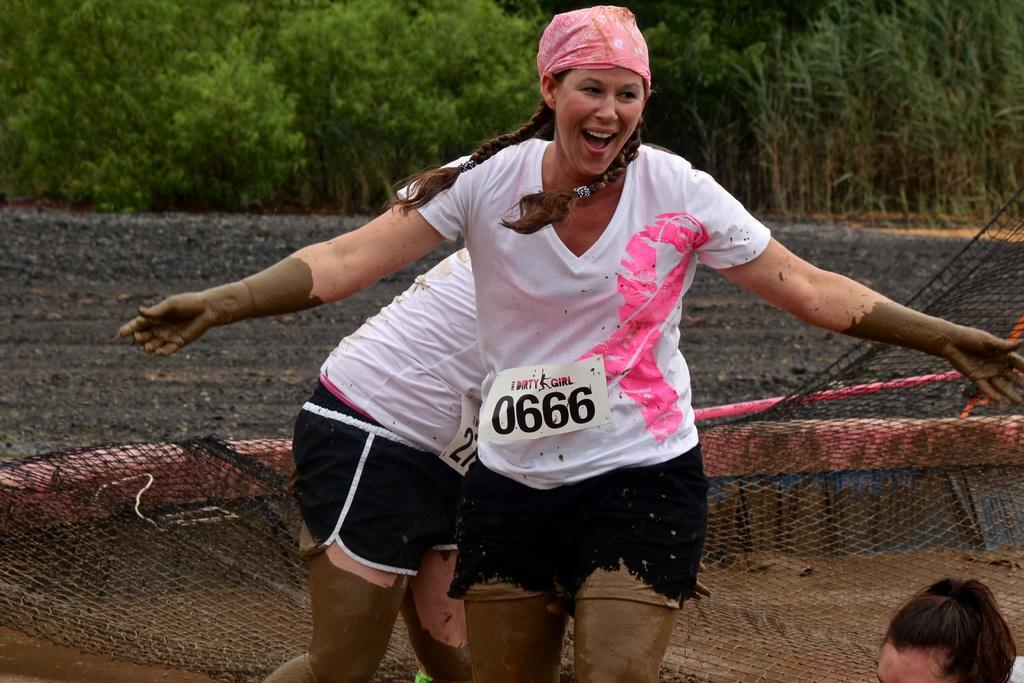<image>
Give a short and clear explanation of the subsequent image. a lady yelling with the number 0666 on herself 